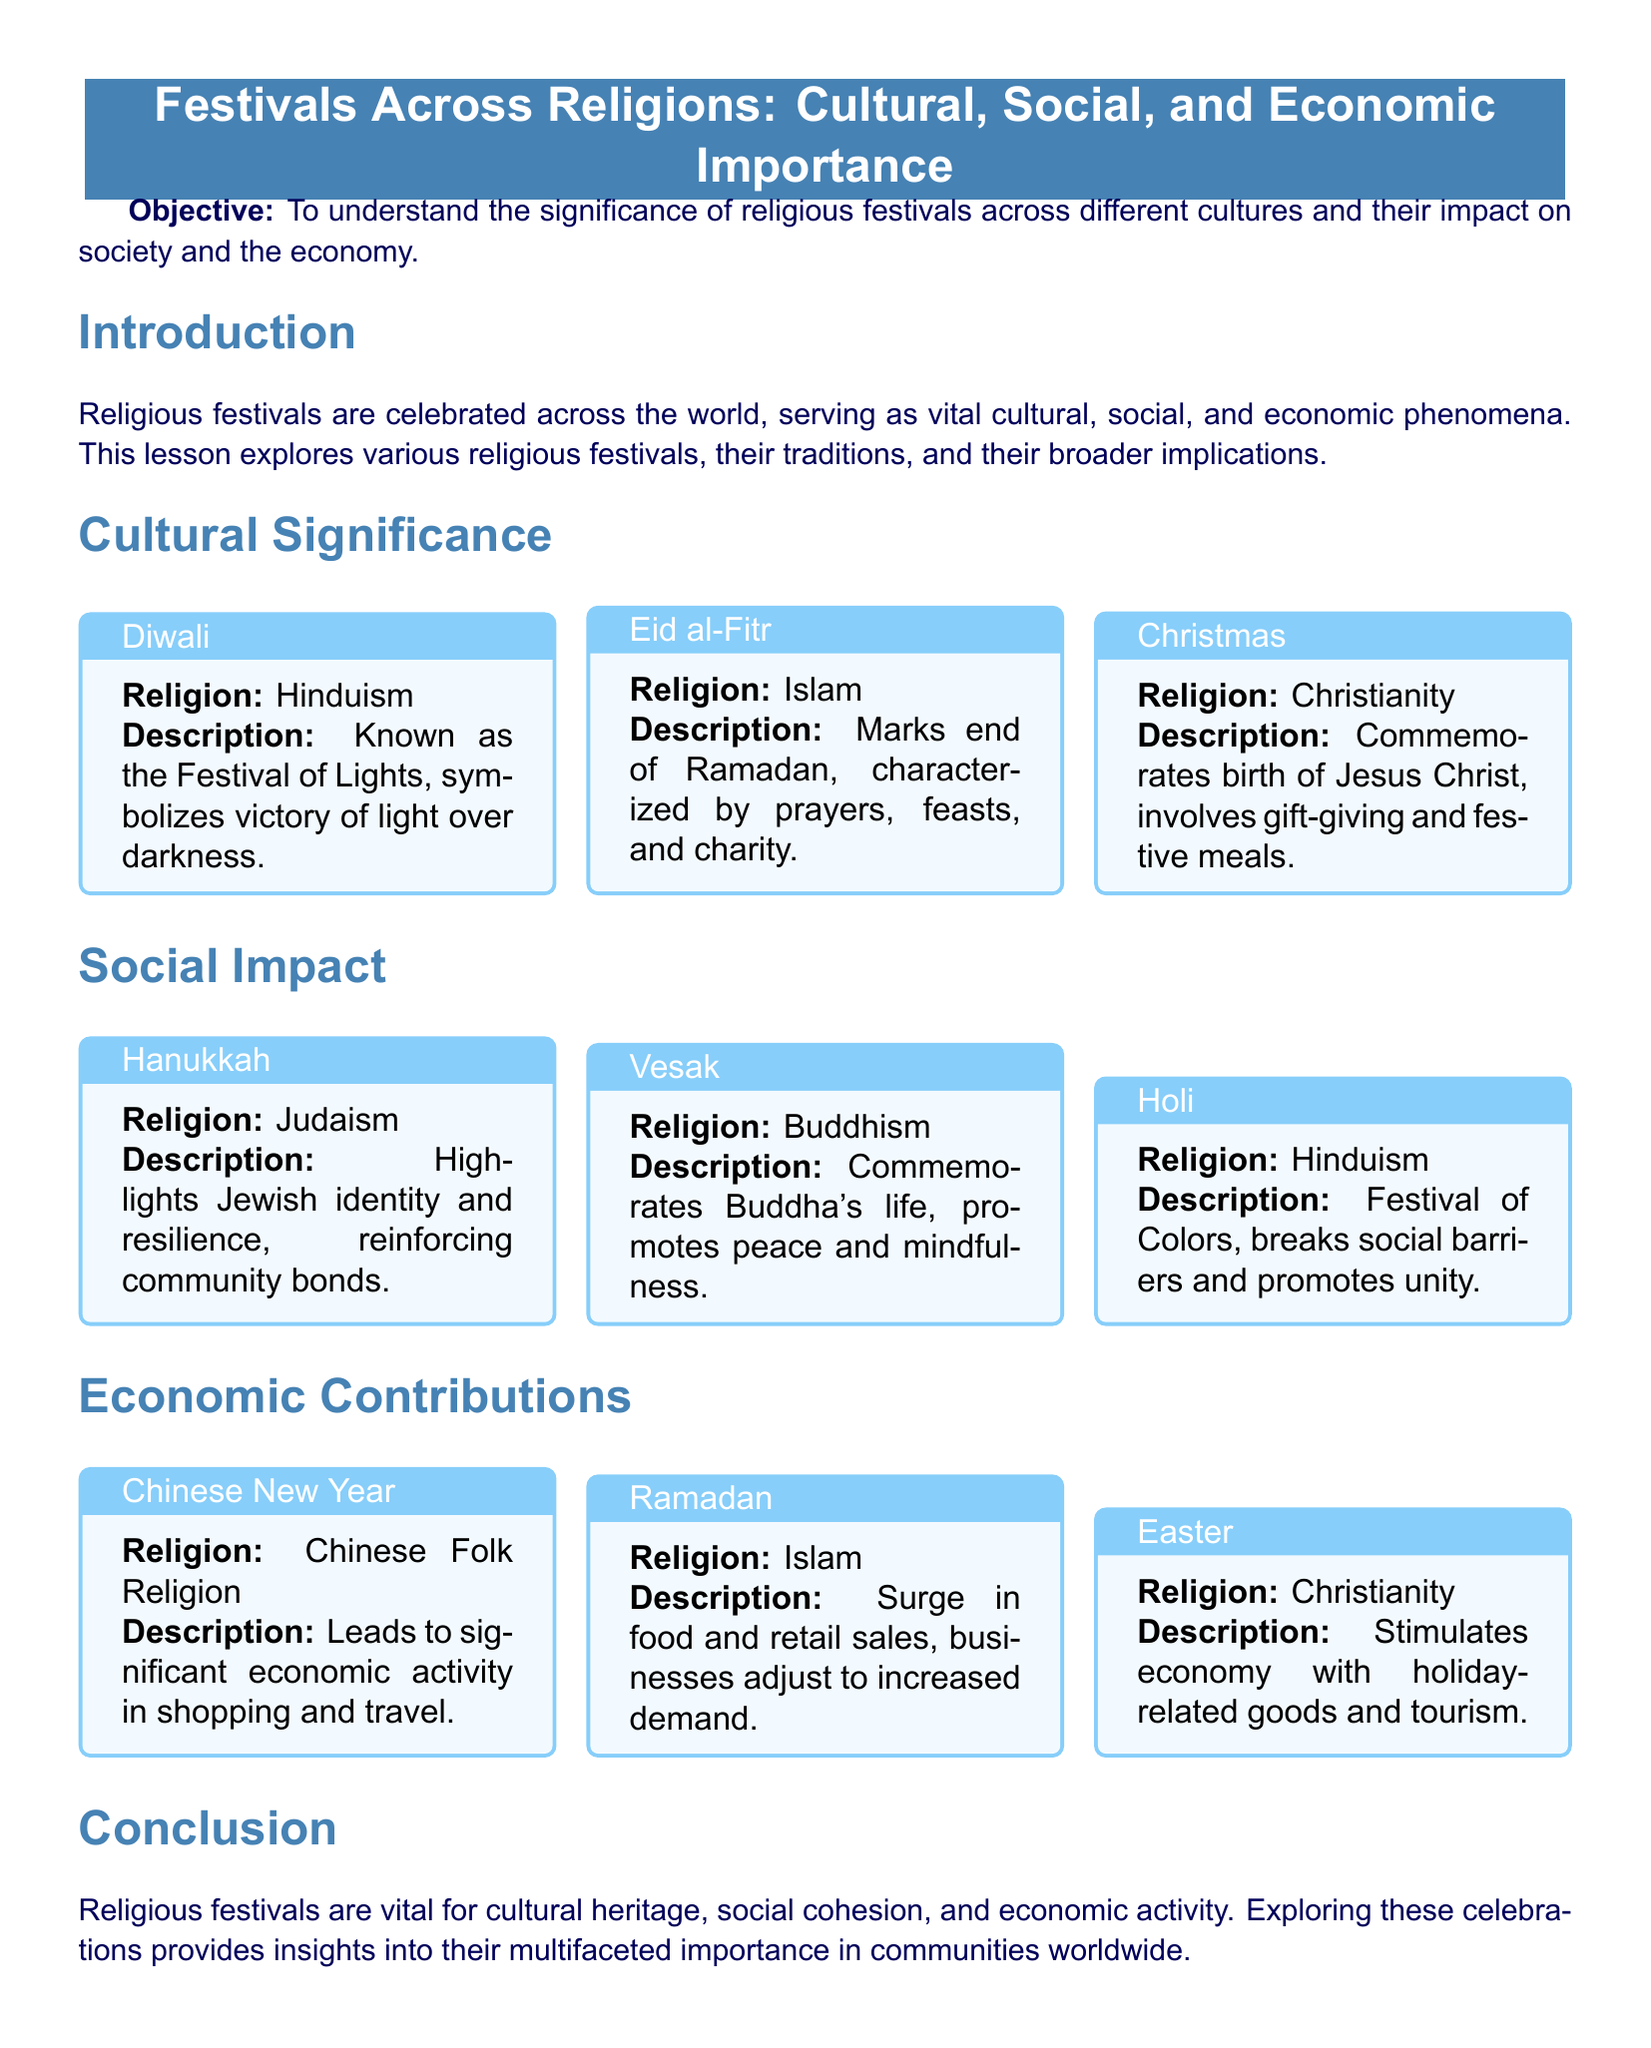what is the main objective of the lesson plan? The objective is stated clearly in the document, focusing on understanding the significance of religious festivals.
Answer: To understand the significance of religious festivals across different cultures and their impact on society and the economy which festival is known as the Festival of Lights? The document identifies Diwali as the Festival of Lights under the cultural significance section.
Answer: Diwali what religious festival marks the end of Ramadan? The document mentions Eid al-Fitr as the festival that marks the end of Ramadan.
Answer: Eid al-Fitr how does the Holi festival promote social interactions? The document explains that Holi breaks social barriers and promotes unity, showing its role in social interactions.
Answer: Promotes unity which festival leads to significant economic activity in shopping and travel? The document states that the Chinese New Year leads to significant economic activity.
Answer: Chinese New Year what impact does Ramadan have on the economy? The document notes there is a surge in food and retail sales during Ramadan, indicating its economic impact.
Answer: Surge in food and retail sales which festival is celebrated to commemorate Buddha's life? The document specifies Vesak as the festival commemorating Buddha's life in the social impact section.
Answer: Vesak how many festivals are mentioned in the cultural significance section? The document lists three festivals in the cultural significance section: Diwali, Eid al-Fitr, and Christmas.
Answer: Three what is the conclusion about the significance of religious festivals? The conclusion summarizes the vital roles of religious festivals in cultural heritage, social cohesion, and economic activity.
Answer: Vital for cultural heritage, social cohesion, and economic activity 